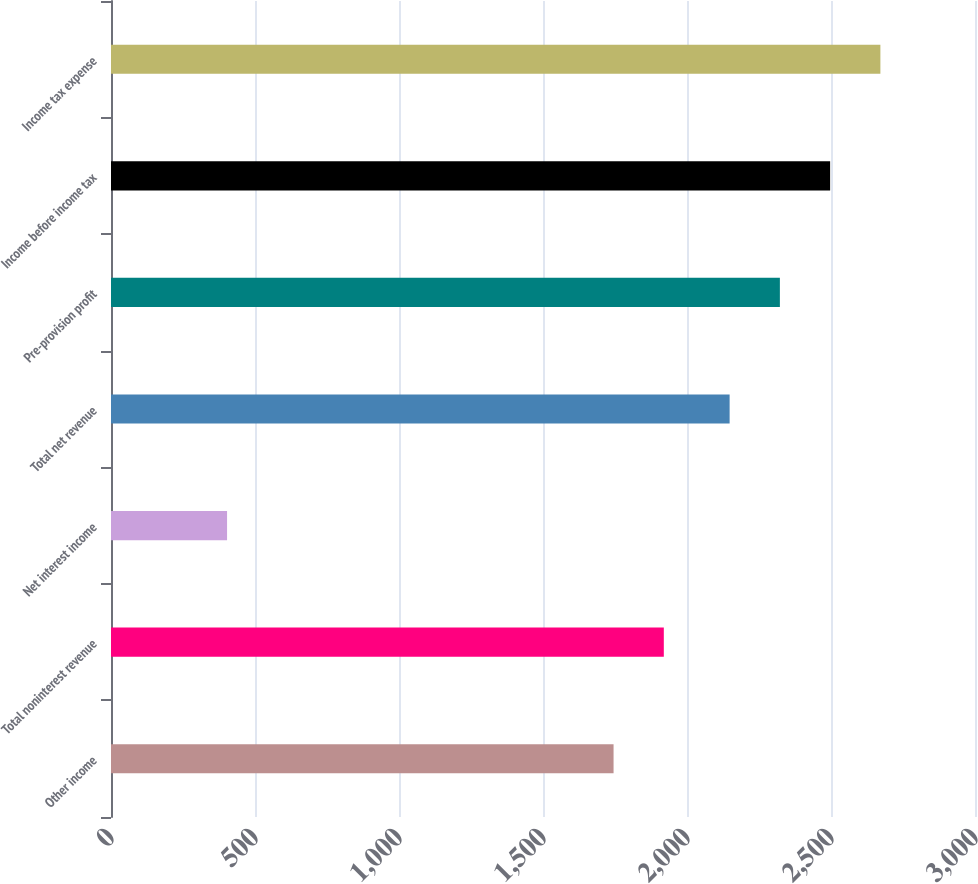Convert chart to OTSL. <chart><loc_0><loc_0><loc_500><loc_500><bar_chart><fcel>Other income<fcel>Total noninterest revenue<fcel>Net interest income<fcel>Total net revenue<fcel>Pre-provision profit<fcel>Income before income tax<fcel>Income tax expense<nl><fcel>1745<fcel>1919.5<fcel>403<fcel>2148<fcel>2322.5<fcel>2497<fcel>2671.5<nl></chart> 